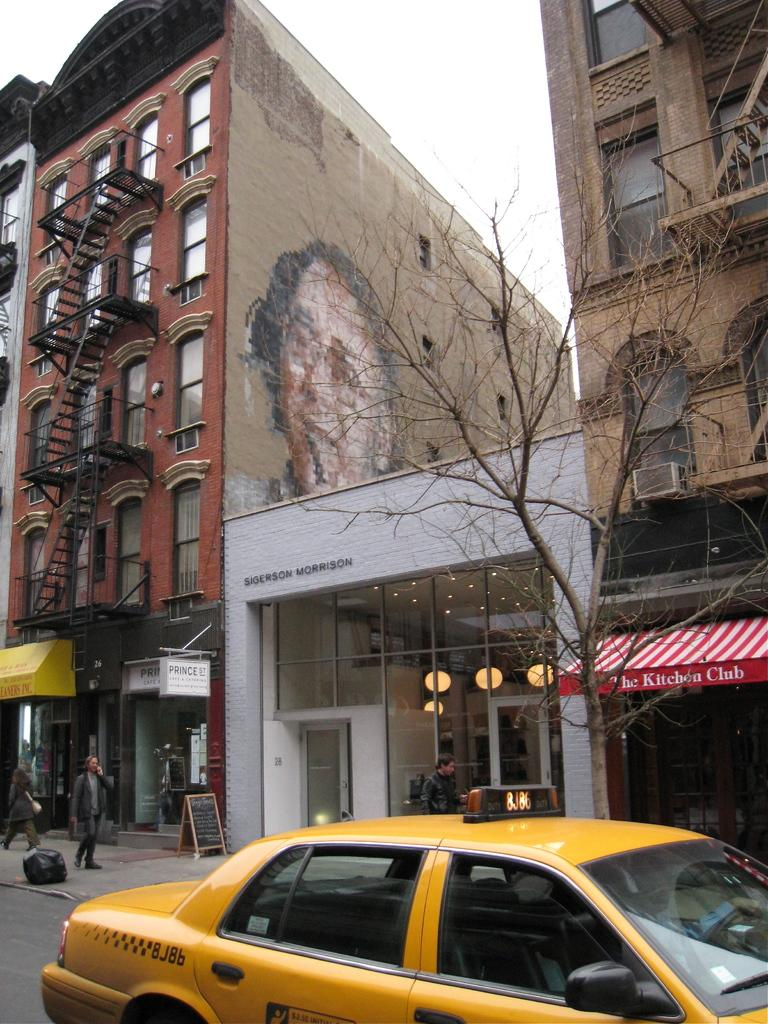<image>
Render a clear and concise summary of the photo. A taxi is outside a building labeled Sigerson Morrison. 